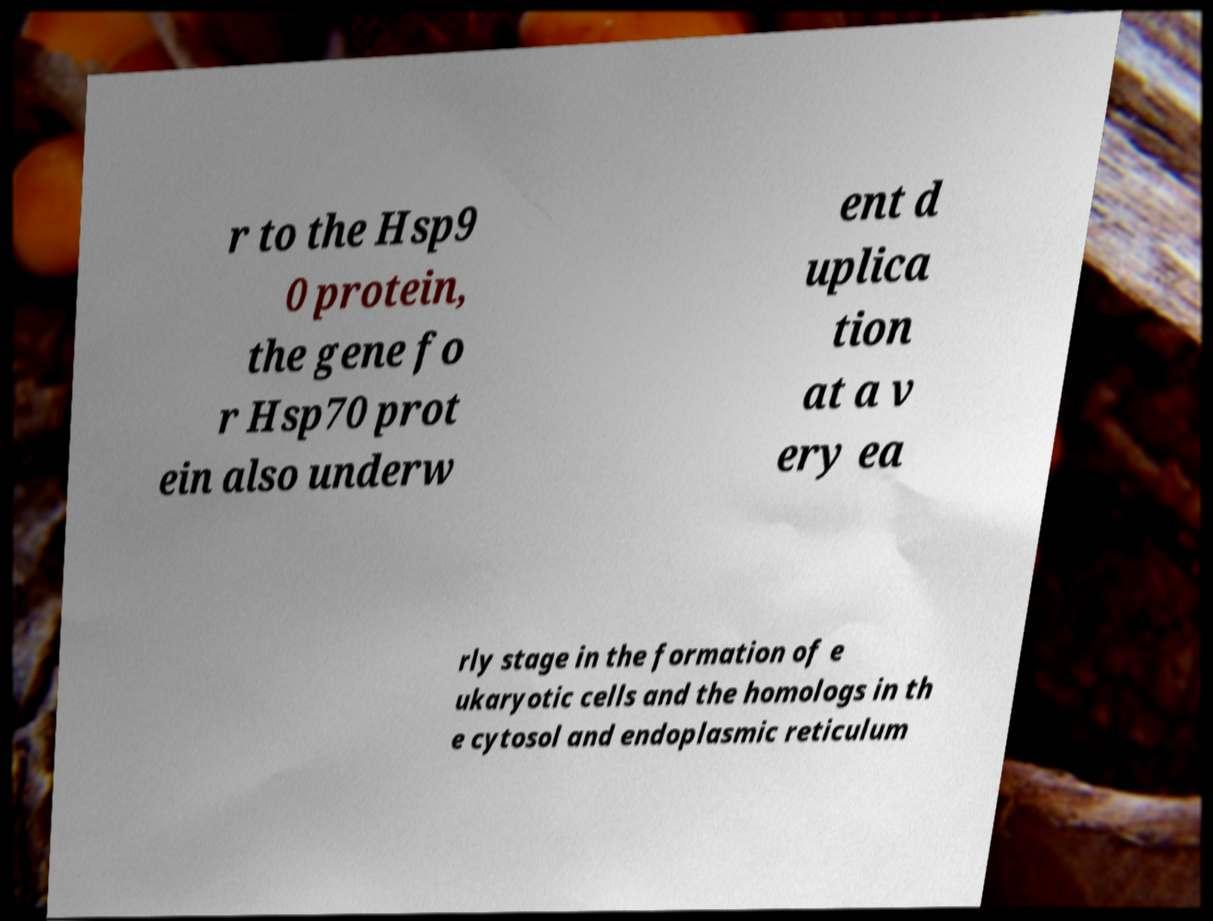What messages or text are displayed in this image? I need them in a readable, typed format. r to the Hsp9 0 protein, the gene fo r Hsp70 prot ein also underw ent d uplica tion at a v ery ea rly stage in the formation of e ukaryotic cells and the homologs in th e cytosol and endoplasmic reticulum 